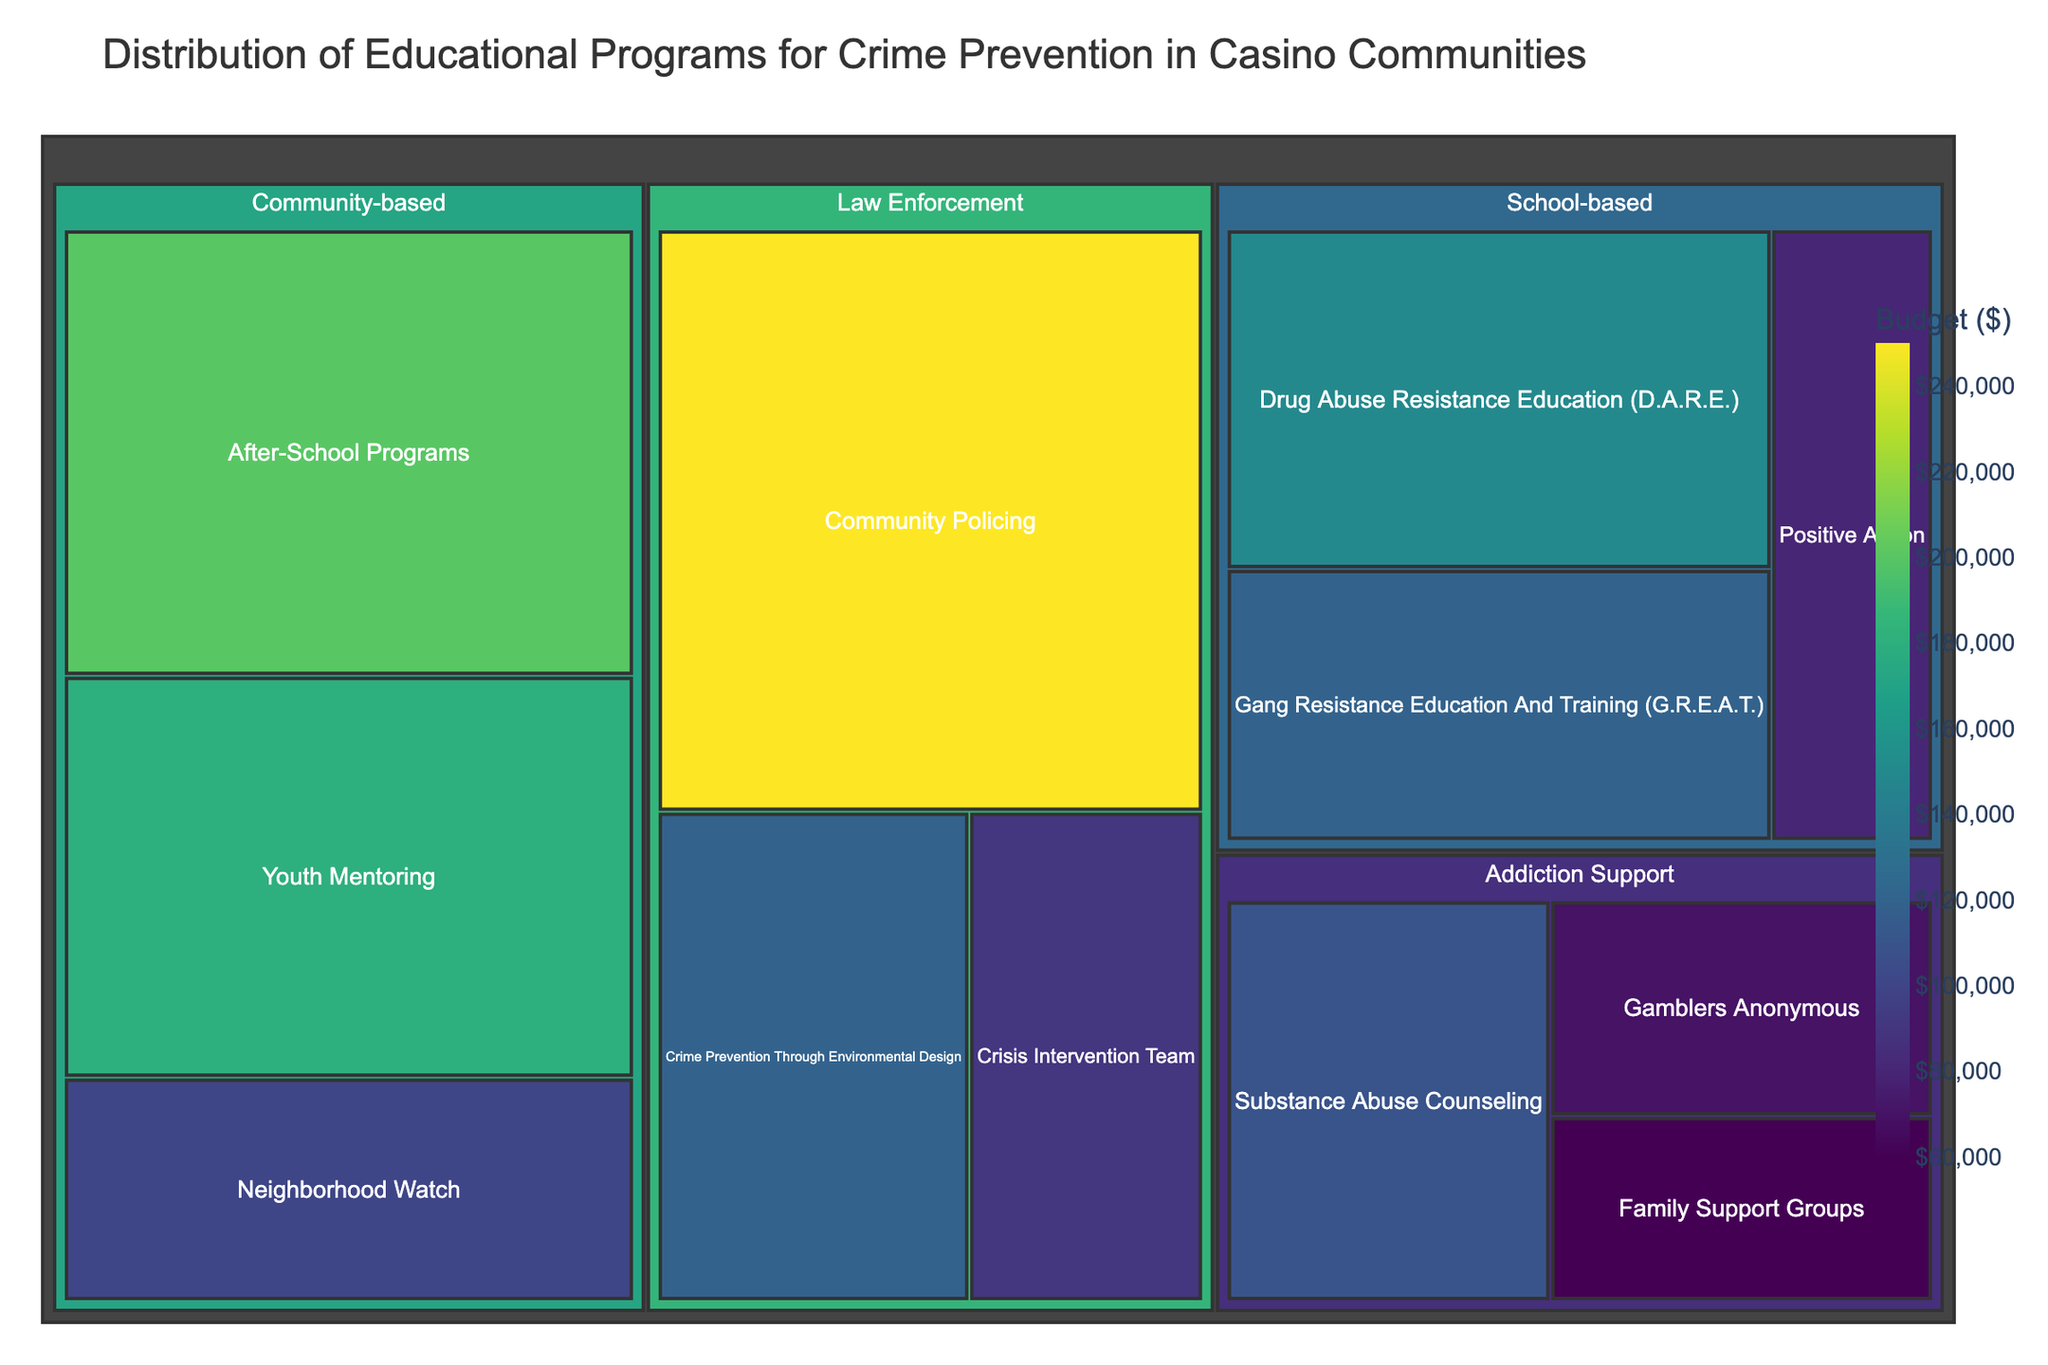What is the title of the figure? The title of the figure is displayed at the top of the image.
Answer: Distribution of Educational Programs for Crime Prevention in Casino Communities Which program has the highest budget? Looking at the largest block in the treemap, we can see that "Community Policing" in the Law Enforcement category has the highest budget.
Answer: Community Policing What is the total budget for School-based programs? Summing the budgets of all the programs under the School-based category: ($150,000 + $120,000 + $80,000)
Answer: $350,000 Which category has the most programs? By counting the number of boxes within each main category in the treemap, we see that Community-based and School-based each have 3, while Law Enforcement has 3 and Addiction Support has 3. While it appears even, we pick one (e.g., Community-based) for clarity without detailed ties inspection.
Answer: Community-based How does the budget for "After-School Programs" compare to "Gamblers Anonymous"? Comparing the sizes of the boxes directly shows that "After-School Programs" ($200,000) has a significantly larger budget than "Gamblers Anonymous" ($70,000).
Answer: After-School Programs has a larger budget What is the combined budget for "Addiction Support" programs? Summing the budgets of all programs under the Addiction Support category: ($70,000 + $110,000 + $60,000)
Answer: $240,000 Which category has the smallest total budget? Visual inspection of the sizes of categories and summing individual budgets shows that Addiction Support has the smallest budget: ($70,000 + $110,000 + $60,000=$240,000). This total is smaller compared to other categories.
Answer: Addiction Support What is the average budget of Law Enforcement programs? First, calculate the total budget for Law Enforcement: ($250,000 + $120,000 + $90,000 = $460,000). Since there are 3 programs, average budget = total budget / number of programs = $460,000 / 3
Answer: $153,333 Which program within the Community-based category has the highest budget? Looking at the Community-based category, "After-School Programs" has the largest block indicating the highest budget of $200,000
Answer: After-School Programs What is the difference in budget between "Drug Abuse Resistance Education (D.A.R.E.)" and "Youth Mentoring"? Subtract the budget of Youth Mentoring ($180,000) from the budget of Drug Abuse Resistance Education (D.A.R.E.) ($150,000): $180,000 - $150,000 = $30,000
Answer: $30,000 